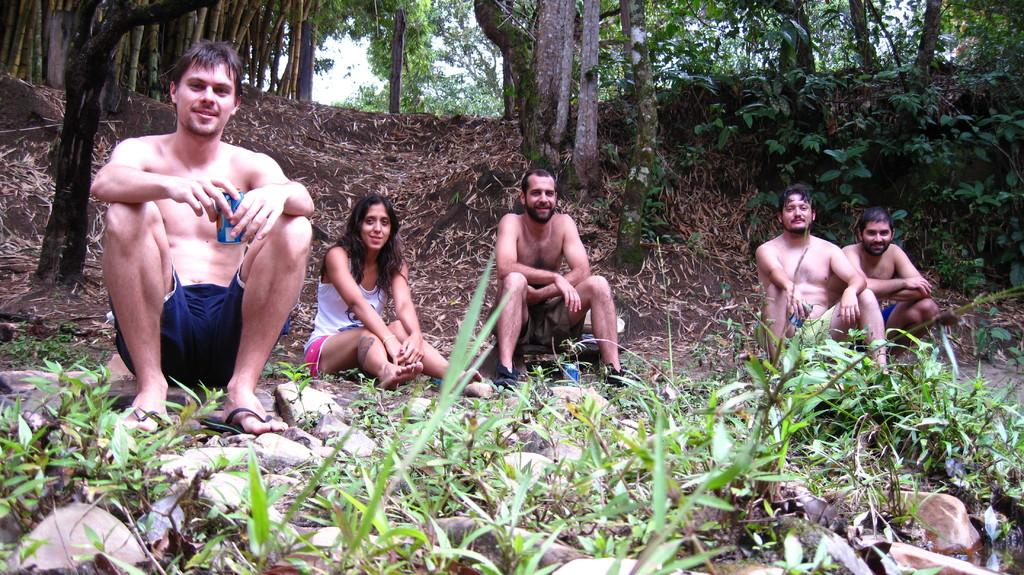What are the people in the image doing? The people in the image are sitting on the ground. What are some of the people holding? Some of the people are holding tins. What can be seen in the background of the image? There are trees in the background of the image. What is present at the bottom of the image? There are plants and rocks at the bottom of the image. What type of fuel is being used by the people in the image? There is no mention of fuel in the image, as the people are sitting on the ground and holding tins. 